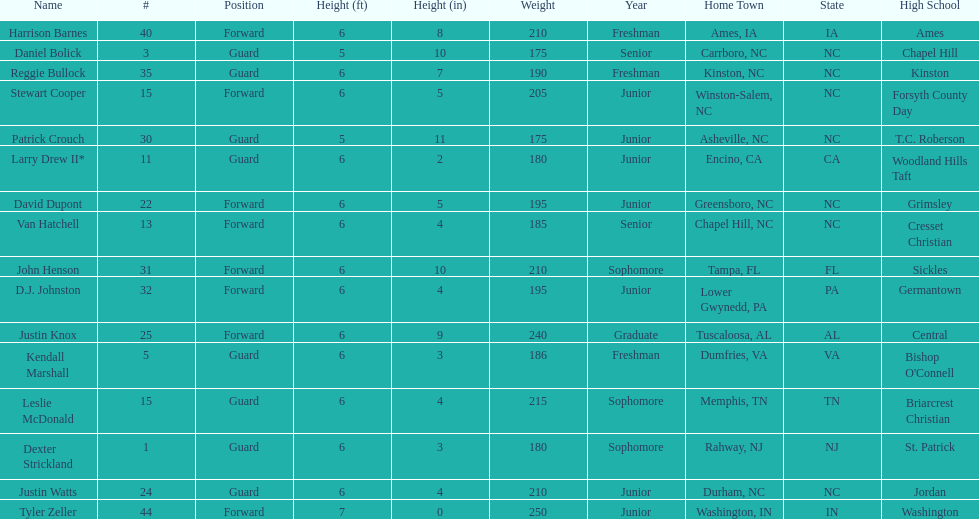How many players are not a junior? 9. 